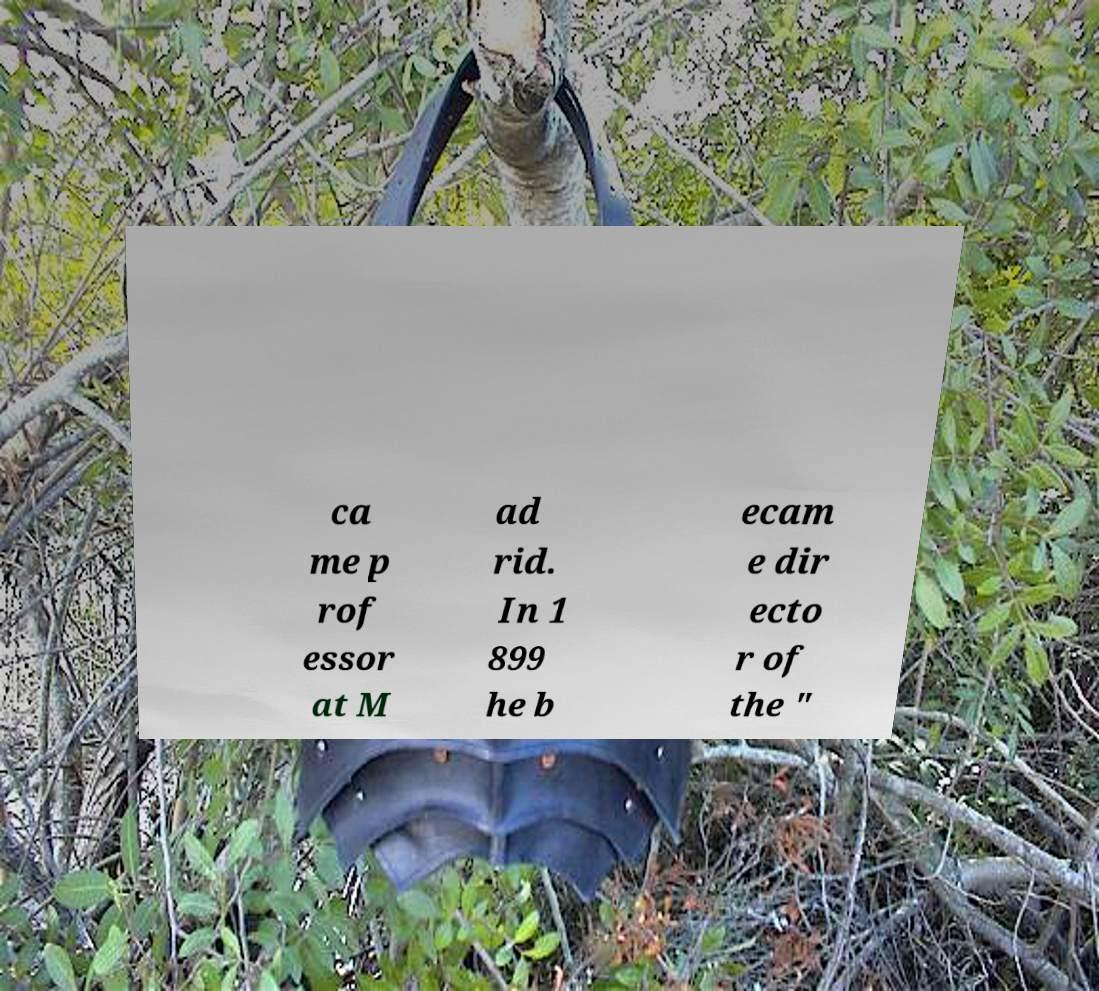What messages or text are displayed in this image? I need them in a readable, typed format. ca me p rof essor at M ad rid. In 1 899 he b ecam e dir ecto r of the " 